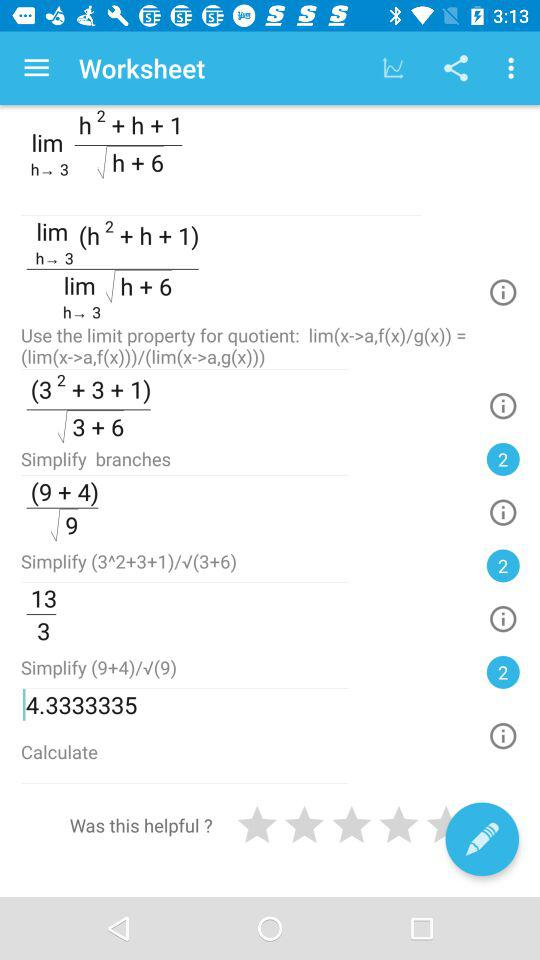What is the value of (9+4)/√(9)?
Answer the question using a single word or phrase. 4.33333335 